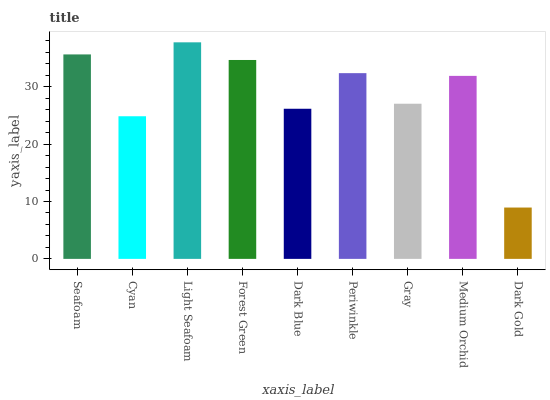Is Dark Gold the minimum?
Answer yes or no. Yes. Is Light Seafoam the maximum?
Answer yes or no. Yes. Is Cyan the minimum?
Answer yes or no. No. Is Cyan the maximum?
Answer yes or no. No. Is Seafoam greater than Cyan?
Answer yes or no. Yes. Is Cyan less than Seafoam?
Answer yes or no. Yes. Is Cyan greater than Seafoam?
Answer yes or no. No. Is Seafoam less than Cyan?
Answer yes or no. No. Is Medium Orchid the high median?
Answer yes or no. Yes. Is Medium Orchid the low median?
Answer yes or no. Yes. Is Cyan the high median?
Answer yes or no. No. Is Dark Gold the low median?
Answer yes or no. No. 